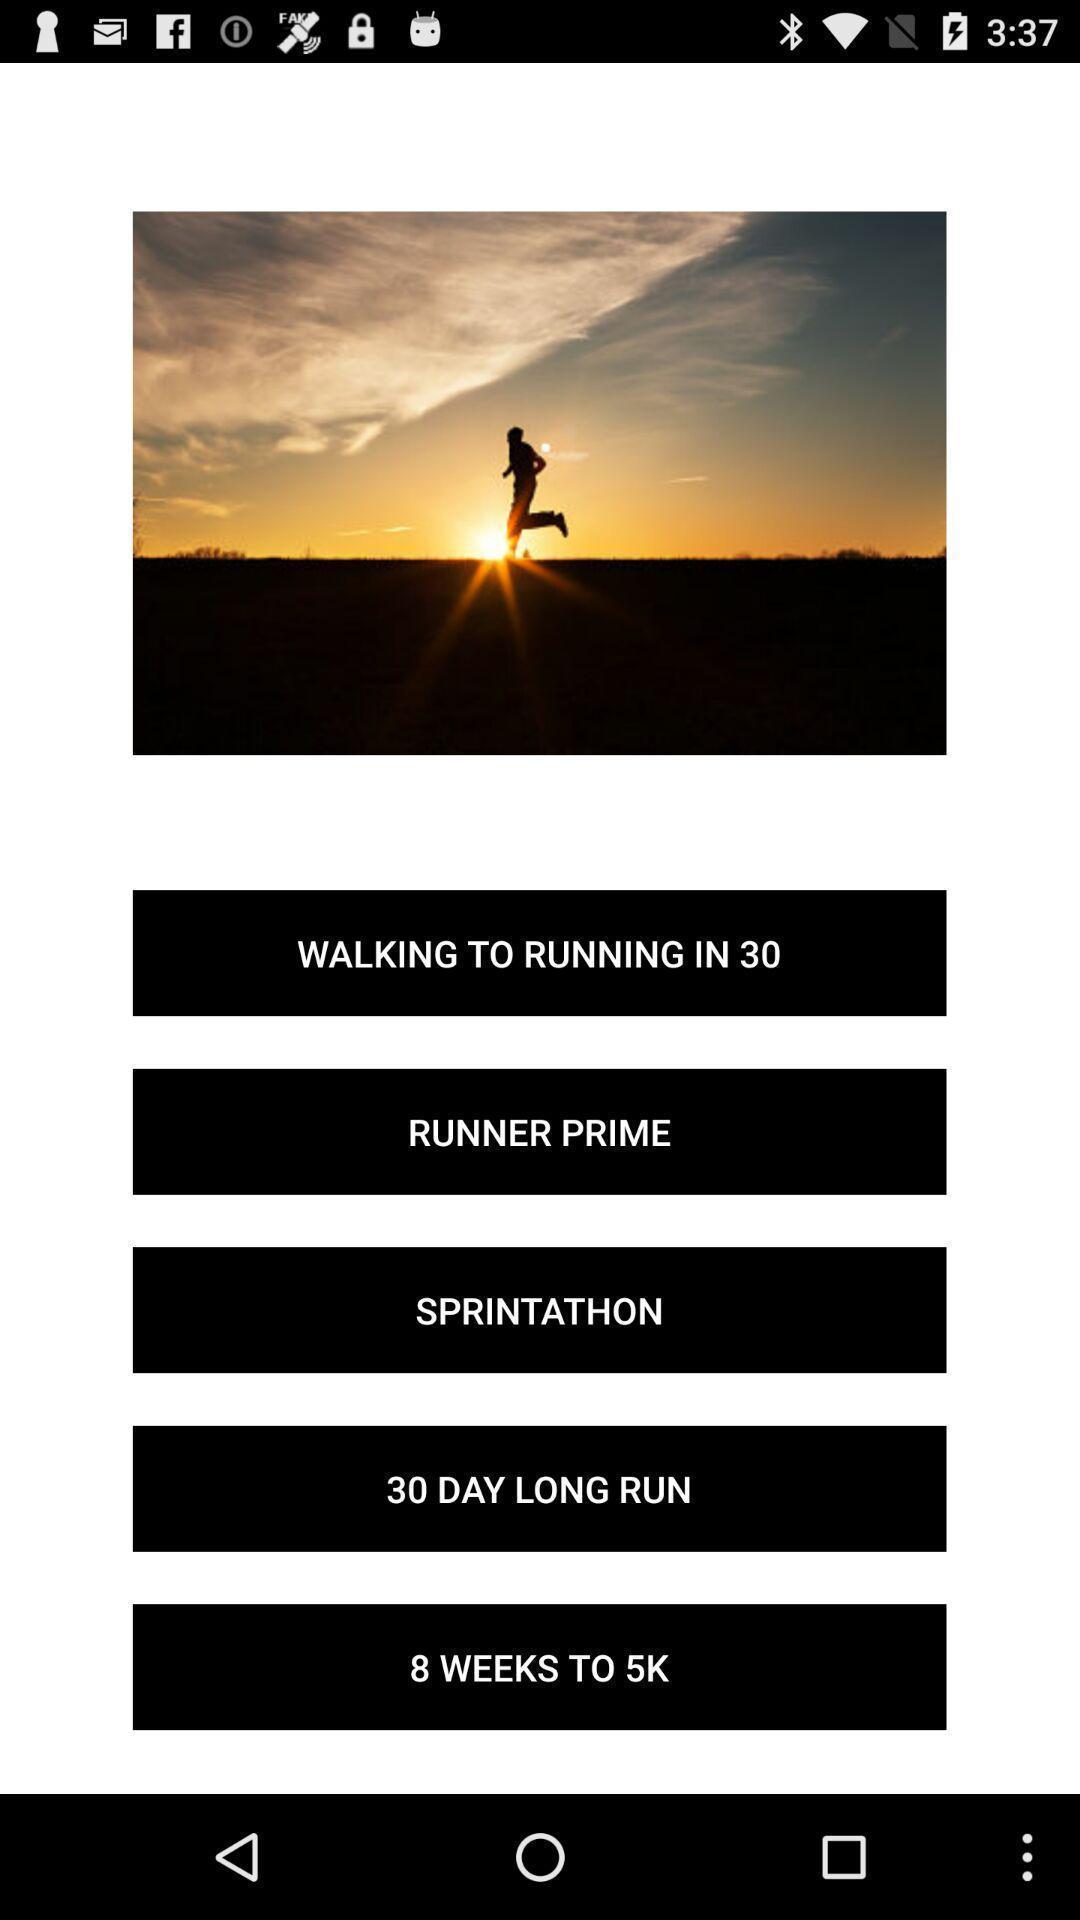What is the overall content of this screenshot? Various options displayed of a fitness training app. 